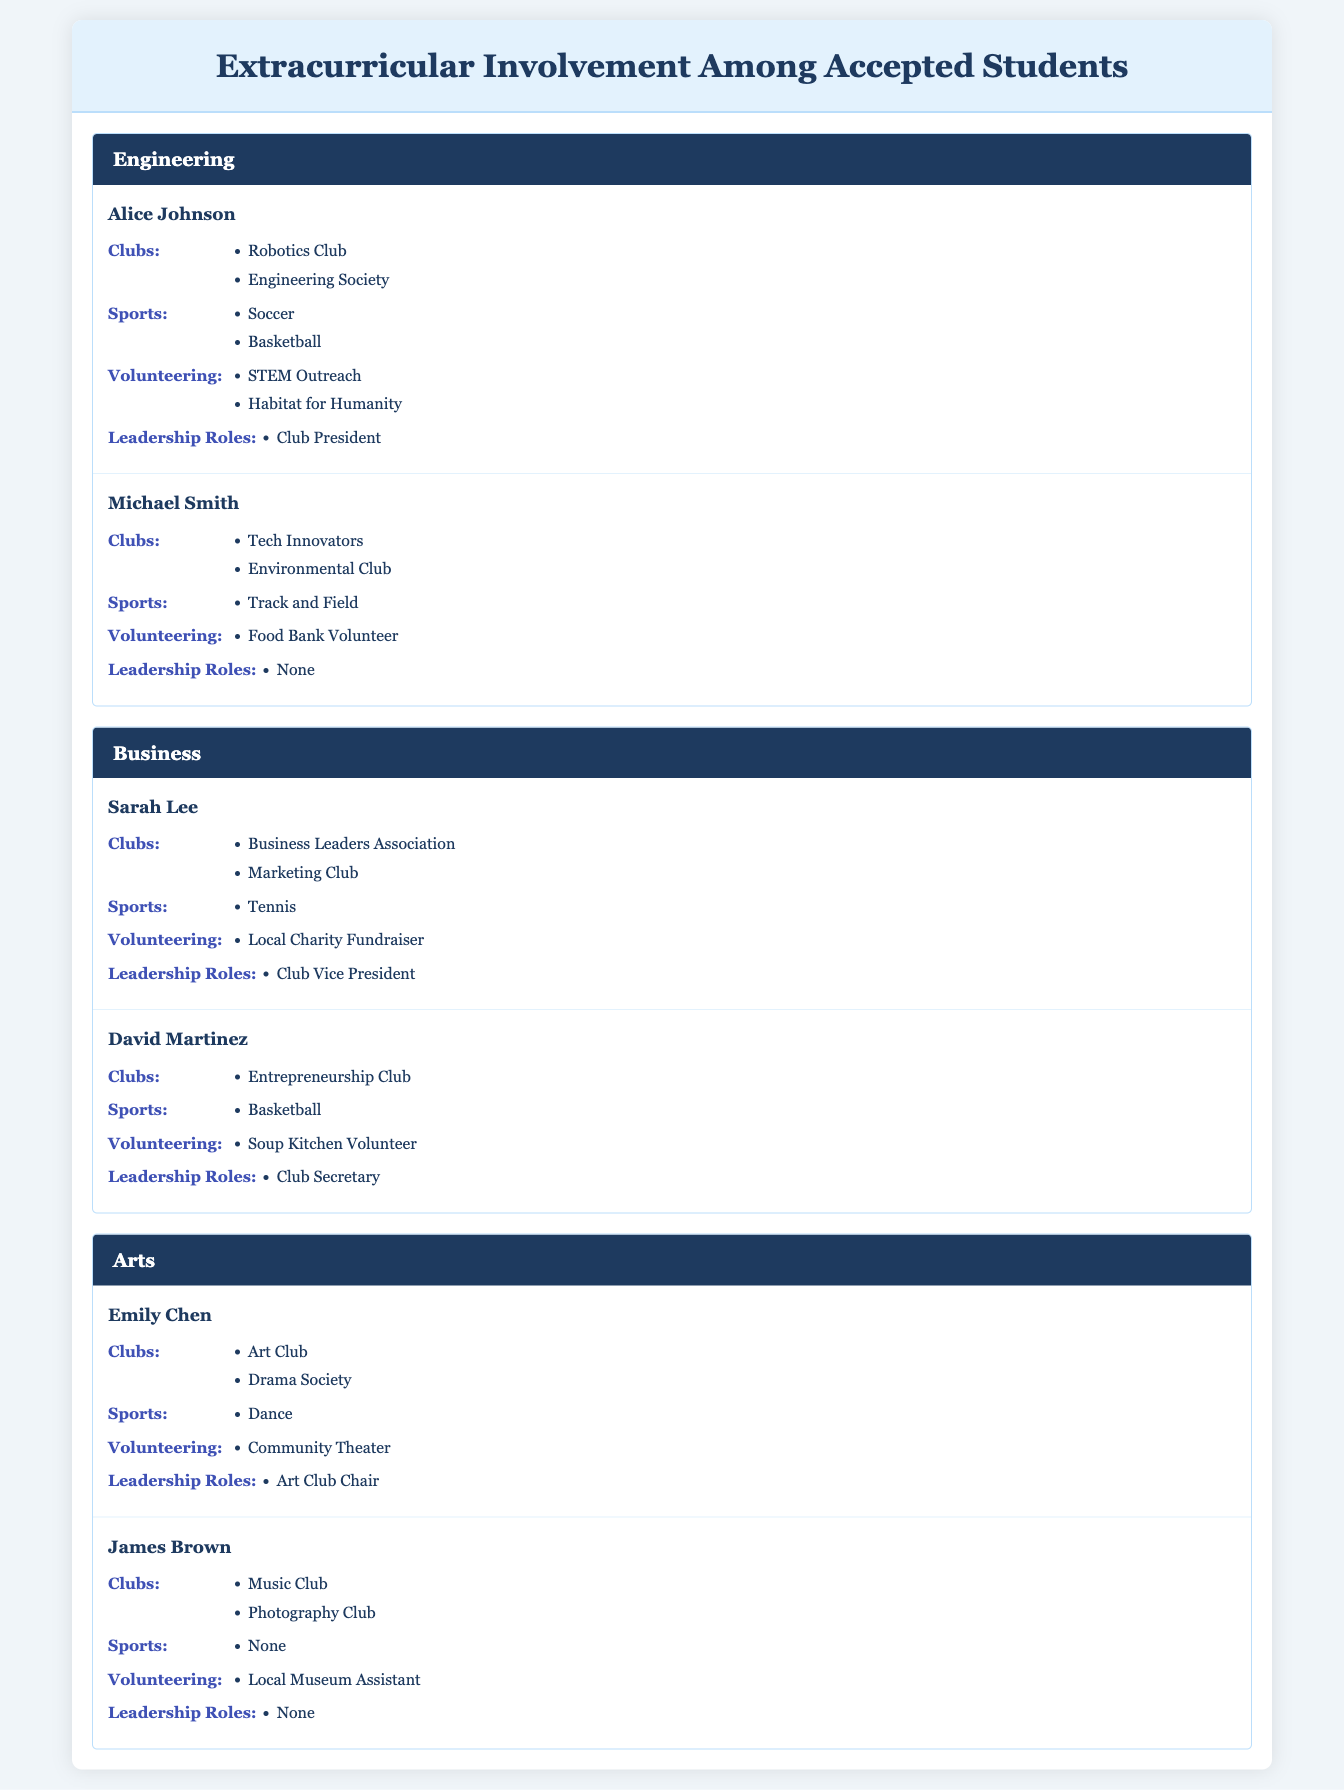What clubs are Alice Johnson involved in? Alice Johnson is involved in the Robotics Club and the Engineering Society, as listed under her extracurriculars in the Engineering program.
Answer: Robotics Club, Engineering Society How many students from the Business program have leadership roles? Sarah Lee and David Martinez from the Business program have leadership roles; Sarah is the Club Vice President and David is the Club Secretary. Thus, there are two students with leadership roles.
Answer: 2 Does James Brown have any sports involvement? No, based on the table, it shows that James Brown does not participate in any sports, as the entry under Sports specifies "None."
Answer: No Which program has the most students listed in extracurriculars? The programs Engineering, Business, and Arts each list two students. Therefore, no single program has more students than the others; they are all equal.
Answer: None What is the total number of volunteering activities listed for all students in the Arts program? Emily Chen has one volunteering activity (Community Theater) and James Brown has one (Local Museum Assistant), totaling 2 volunteering activities for the Arts program.
Answer: 2 How many leadership roles are mentioned across all students? Alice Johnson has one leadership role (Club President), Sarah Lee has one (Club Vice President), David Martinez has one (Club Secretary), and Emily Chen has one (Art Club Chair). James Brown has none. Thus, there are a total of four leadership roles mentioned.
Answer: 4 Which student has the most extracurricular activities listed? Alice Johnson has the most extracurricular activities overall: 2 clubs, 2 sports, 2 volunteering activities, and 1 leadership role, totaling 7 activities.
Answer: Alice Johnson Are there any students without any leadership roles? Yes, both Michael Smith and James Brown do not have any leadership roles listed in their extracurricular activities. Thus, the answer is yes.
Answer: Yes What is the average number of clubs per student in the Engineering program? Alice Johnson is a member of 2 clubs and Michael Smith is a member of 2 clubs as well, giving a total of 4 clubs for 2 students. Therefore, the average number of clubs is 4 divided by 2, which is 2.
Answer: 2 